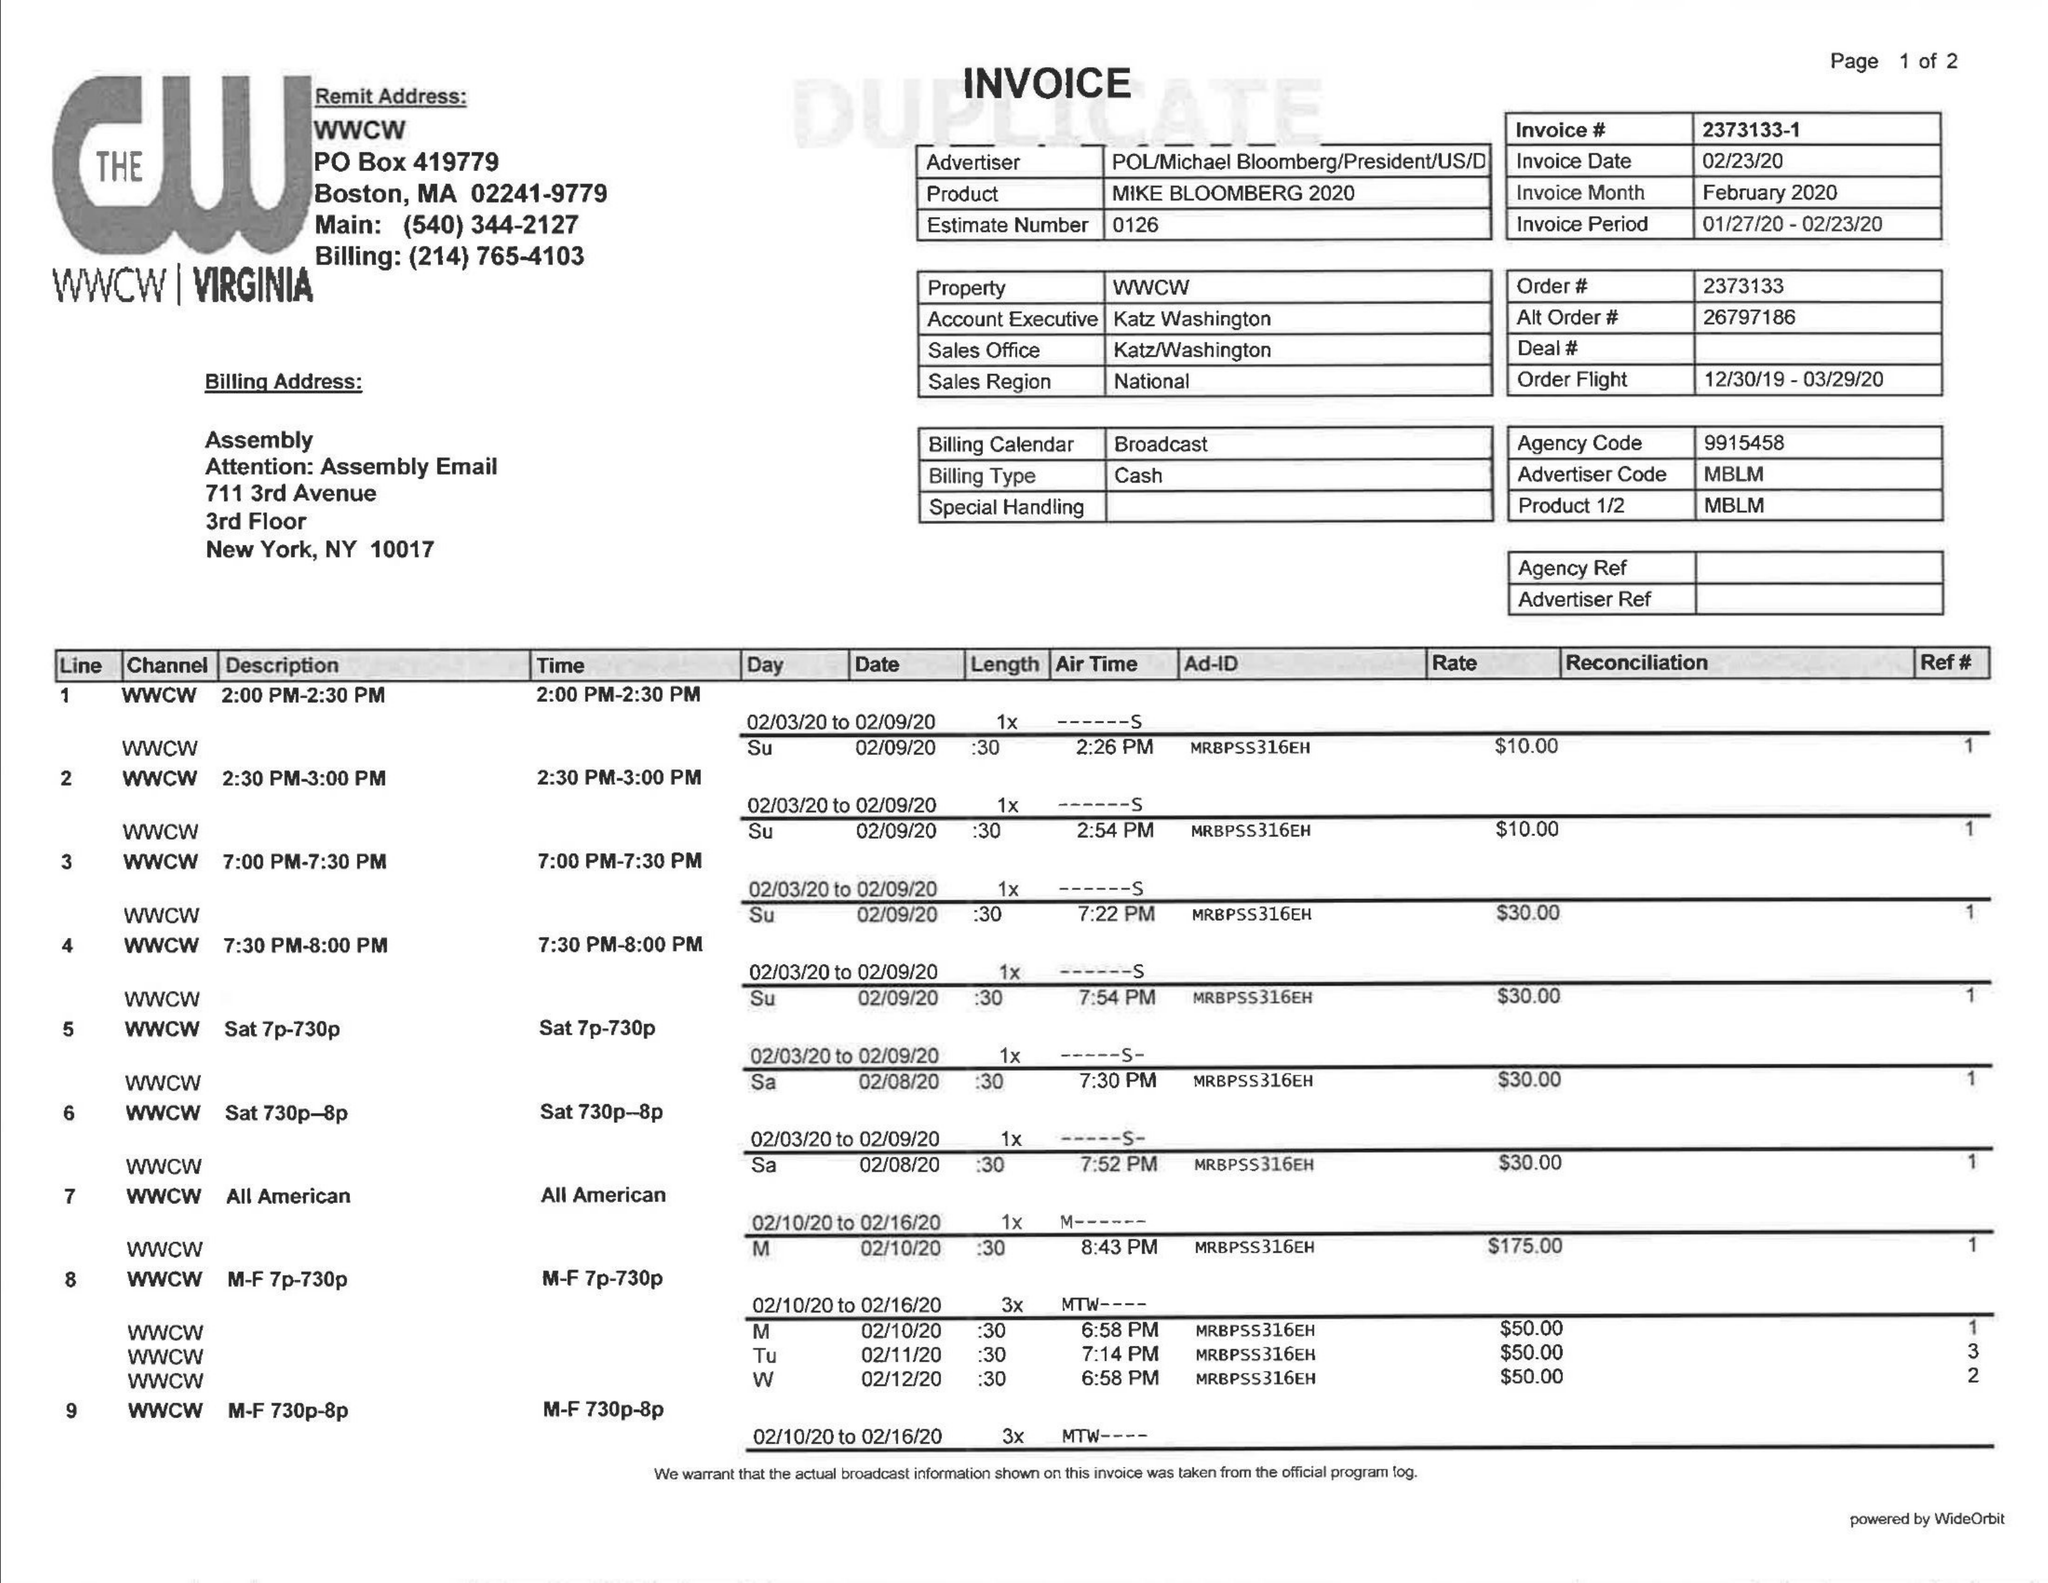What is the value for the gross_amount?
Answer the question using a single word or phrase. 630.00 